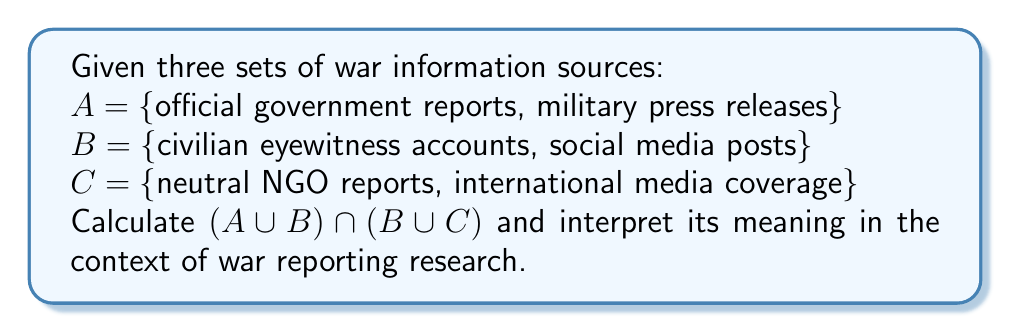Teach me how to tackle this problem. Let's approach this step-by-step:

1) First, let's calculate $A \cup B$:
   $A \cup B$ = {official government reports, military press releases, civilian eyewitness accounts, social media posts}

2) Next, let's calculate $B \cup C$:
   $B \cup C$ = {civilian eyewitness accounts, social media posts, neutral NGO reports, international media coverage}

3) Now, we need to find the intersection of these two sets:
   $(A \cup B) \cap (B \cup C)$ = {civilian eyewitness accounts, social media posts}

4) Interpretation:
   The resulting set represents information sources that are either from set $B$ alone or common to any two of the sets. In the context of war reporting research, these are sources that bridge the gap between official narratives (set $A$) and independent reports (set $C$). They represent first-hand accounts and user-generated content, which can provide alternative viewpoints to official narratives and complement professional journalistic coverage.

5) This result highlights the importance of civilian perspectives in war reporting, as they appear in both the combination of official and unofficial sources $(A \cup B)$ and the mix of unofficial and independent sources $(B \cup C)$.
Answer: $\{$civilian eyewitness accounts, social media posts$\}$ 